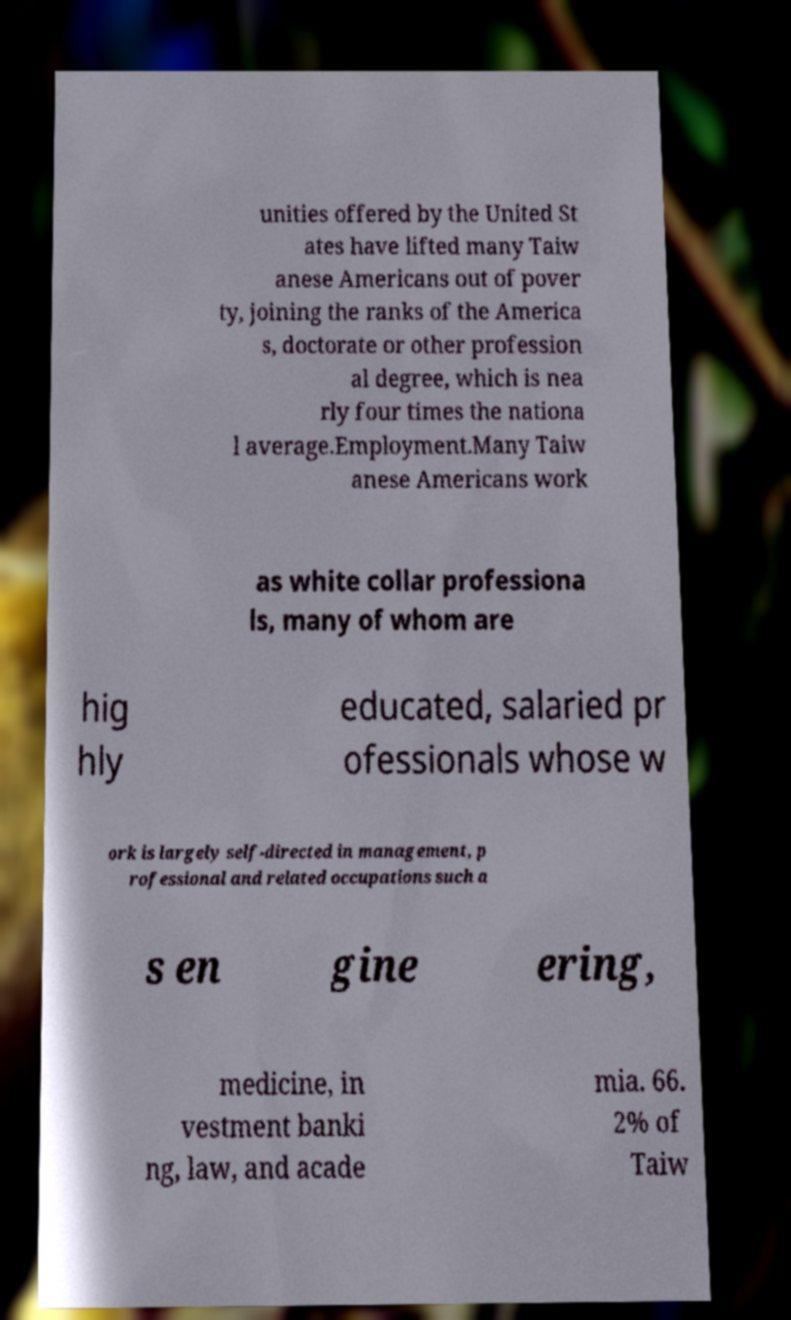Could you assist in decoding the text presented in this image and type it out clearly? unities offered by the United St ates have lifted many Taiw anese Americans out of pover ty, joining the ranks of the America s, doctorate or other profession al degree, which is nea rly four times the nationa l average.Employment.Many Taiw anese Americans work as white collar professiona ls, many of whom are hig hly educated, salaried pr ofessionals whose w ork is largely self-directed in management, p rofessional and related occupations such a s en gine ering, medicine, in vestment banki ng, law, and acade mia. 66. 2% of Taiw 